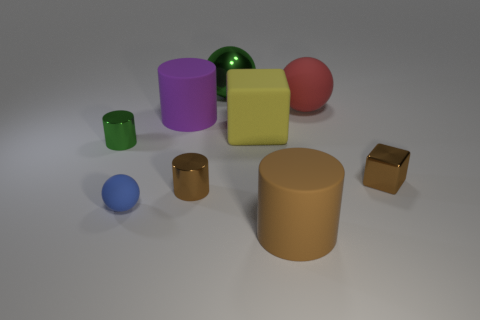Subtract all brown shiny cylinders. How many cylinders are left? 3 Subtract all brown blocks. How many brown cylinders are left? 2 Subtract 2 cylinders. How many cylinders are left? 2 Add 1 blue spheres. How many objects exist? 10 Subtract all green cylinders. How many cylinders are left? 3 Subtract all spheres. How many objects are left? 6 Subtract all purple balls. Subtract all yellow cubes. How many balls are left? 3 Add 9 red rubber balls. How many red rubber balls are left? 10 Add 2 purple matte balls. How many purple matte balls exist? 2 Subtract 0 red cubes. How many objects are left? 9 